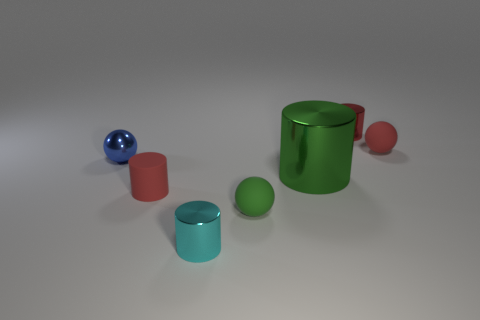Are there any other things that have the same size as the green cylinder?
Provide a short and direct response. No. What size is the green metal object that is the same shape as the small red metallic object?
Give a very brief answer. Large. What material is the small cyan cylinder?
Your response must be concise. Metal. What material is the small cylinder that is to the right of the metal thing in front of the red cylinder to the left of the large green cylinder?
Your answer should be compact. Metal. What color is the other shiny thing that is the same shape as the tiny green object?
Keep it short and to the point. Blue. There is a cylinder behind the big metal thing; is its color the same as the tiny rubber thing that is left of the tiny cyan object?
Offer a terse response. Yes. Is the number of red objects that are behind the small rubber cylinder greater than the number of green balls?
Ensure brevity in your answer.  Yes. What number of other things are the same size as the green matte ball?
Your response must be concise. 5. What number of tiny cylinders are both behind the small blue ball and to the left of the small green rubber thing?
Offer a very short reply. 0. Is the red object that is in front of the big green metallic cylinder made of the same material as the tiny green thing?
Offer a terse response. Yes. 